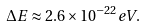Convert formula to latex. <formula><loc_0><loc_0><loc_500><loc_500>\Delta E \approx 2 . 6 \times 1 0 ^ { - 2 2 } e V .</formula> 